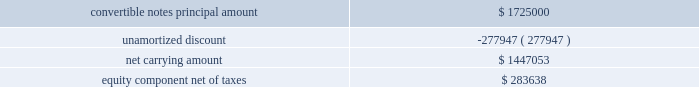Table of contents as of september 25 , 2010 , the carrying amount of the original notes and related equity component ( recorded in capital in excess of par value , net of deferred taxes ) consisted of the following: .
As noted above , on november 18 , 2010 , the company executed separate , privately-negotiated exchange agreements , and the company retired $ 450.0 million in aggregate principal of its original notes for $ 450.0 million in aggregate principal of exchange notes .
The company accounted for this retirement under the derecognition provisions of subtopic asc 470-20-40 , which requires the allocation of the fair value of the consideration transferred ( i.e. , the exchange notes ) between the liability and equity components of the original instrument to determine the gain or loss on the transaction .
In connection with this transaction , the company recorded a loss on extinguishment of debt of $ 29.9 million , which is comprised of the loss on the debt itself of $ 26.0 million and the write-off of the pro-rata amount of debt issuance costs of $ 3.9 million allocated to the notes retired .
The loss on the debt itself is calculated as the difference between the fair value of the liability component of the original notes 2019 amount retired immediately before the exchange and its related carrying value immediately before the exchange .
The fair value of the liability component was calculated similar to the description above for initially recording the original notes under fsp apb 14-1 , and the company used an effective interest rate of 5.46% ( 5.46 % ) , representing the estimated nonconvertible debt borrowing rate with a three year maturity at the measurement date .
In addition , under this accounting standard , a portion of the fair value of the consideration transferred is allocated to the reacquisition of the equity component , which is the difference between the fair value of the consideration transferred and the fair value of the liability component immediately before the exchange .
As a result , $ 39.9 million was allocated to the reacquisition of the equity component of the original instrument , which is recorded net of deferred taxes within capital in excess of par value .
Since the exchange notes have the same characteristics as the original notes and can be settled in cash or a combination of cash and shares of common stock ( i.e. , partial settlement ) , the company is required to account for the liability and equity components of its exchange notes separately to reflect its nonconvertible debt borrowing rate .
The company estimated the fair value of the exchange notes liability component to be $ 349.0 million using a discounted cash flow technique .
Key inputs used to estimate the fair value of the liability component included the company 2019s estimated nonconvertible debt borrowing rate as of november 18 , 2010 ( the date the convertible notes were issued ) , the amount and timing of cash flows , and the expected life of the exchange notes .
The company used an estimated effective interest rate of 6.52% ( 6.52 % ) .
The excess of the fair value transferred over the estimated fair value of the liability component totaling $ 97.3 million was allocated to the conversion feature as an increase to capital in excess of par value with a corresponding offset recognized as a discount to reduce the net carrying value of the exchange notes .
As a result of the fair value of the exchange notes being lower than the exchange notes principal value , there is an additional discount on the exchange notes of $ 3.7 million at the measurement date .
The total discount is being amortized to interest expense over a six-year period ending december 15 , 2016 ( the expected life of the liability component ) using the effective interest method .
In addition , third-party transaction costs have been allocated to the liability and equity components based on the relative values of these components .
Source : hologic inc , 10-k , november 23 , 2011 powered by morningstar ae document research 2120 the information contained herein may not be copied , adapted or distributed and is not warranted to be accurate , complete or timely .
The user assumes all risks for any damages or losses arising from any use of this information , except to the extent such damages or losses cannot be limited or excluded by applicable law .
Past financial performance is no guarantee of future results. .
What is the total percentage of unamortized discount relative to the principal amount of notes? 
Computations: (277947 / 1725000)
Answer: 0.16113. 